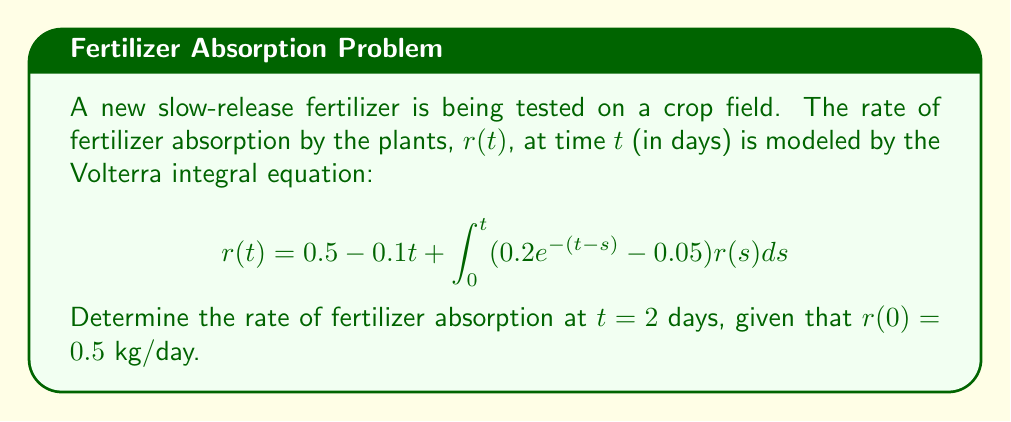Can you solve this math problem? To solve this Volterra integral equation, we'll use an iterative approach:

1) First, let's define our initial approximation $r_0(t)$ using the non-integral terms:
   $$r_0(t) = 0.5 - 0.1t$$

2) Now, we'll use this to calculate our first approximation $r_1(t)$:
   $$r_1(t) = 0.5 - 0.1t + \int_0^t (0.2e^{-(t-s)} - 0.05)(0.5 - 0.1s)ds$$

3) Let's evaluate this integral:
   $$\begin{align}
   r_1(t) &= 0.5 - 0.1t + 0.1\int_0^t e^{-(t-s)}ds - 0.01\int_0^t se^{-(t-s)}ds - 0.025t + 0.0025t^2 \\
   &= 0.5 - 0.1t + 0.1[-e^{-(t-s)}]_0^t + 0.01[-e^{-(t-s)}(s+1)]_0^t - 0.025t + 0.0025t^2 \\
   &= 0.5 - 0.1t + 0.1(1-e^{-t}) + 0.01(-(t+1)+e^{-t}) - 0.025t + 0.0025t^2 \\
   &= 0.6 - 0.135t + 0.0025t^2 + 0.1e^{-t} + 0.01e^{-t}
   \end{align}$$

4) Now, we evaluate $r_1(2)$:
   $$\begin{align}
   r_1(2) &= 0.6 - 0.135(2) + 0.0025(2)^2 + 0.11e^{-2} \\
   &= 0.6 - 0.27 + 0.01 + 0.11e^{-2} \\
   &\approx 0.3809 \text{ kg/day}
   \end{align}$$

5) For better accuracy, we could continue this process to find $r_2(t)$, $r_3(t)$, etc., but $r_1(2)$ gives us a good approximation.
Answer: $0.3809$ kg/day 